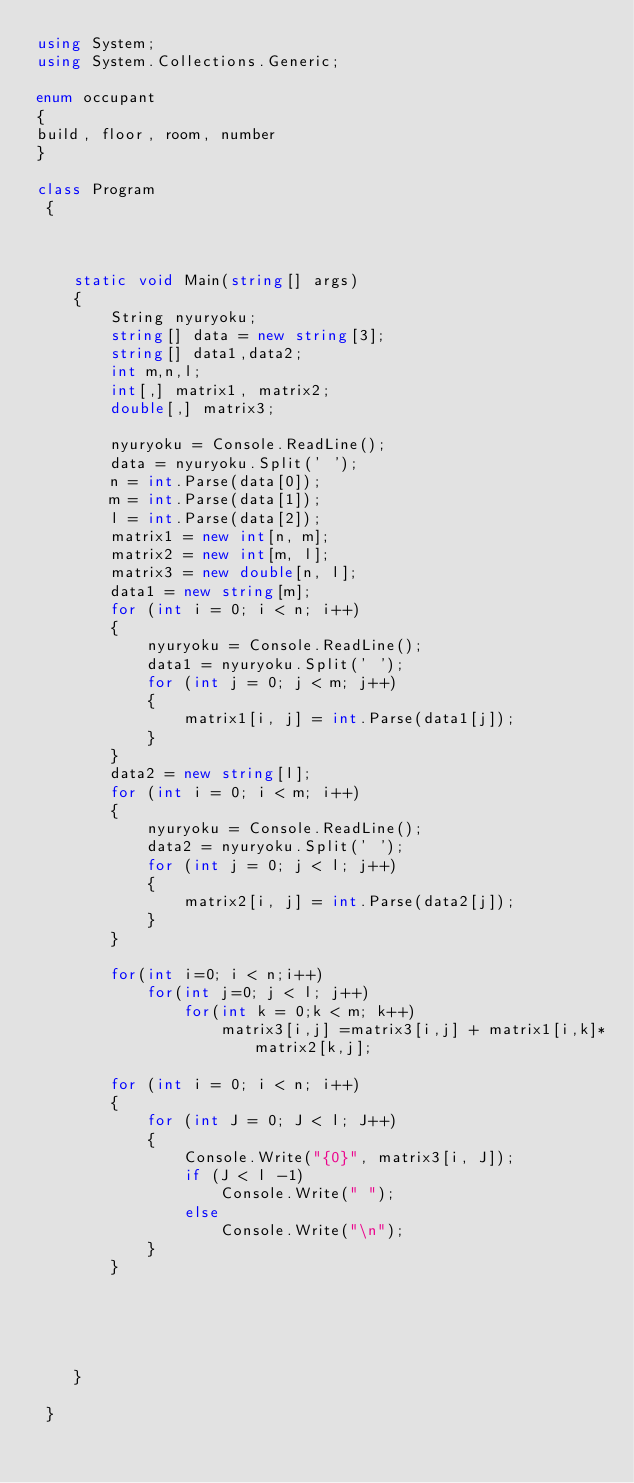<code> <loc_0><loc_0><loc_500><loc_500><_C#_>using System;
using System.Collections.Generic;

enum occupant
{
build, floor, room, number
}

class Program
 {



    static void Main(string[] args)
    {
        String nyuryoku;
        string[] data = new string[3];
        string[] data1,data2;
        int m,n,l;
        int[,] matrix1, matrix2;
        double[,] matrix3;

        nyuryoku = Console.ReadLine();
        data = nyuryoku.Split(' ');
        n = int.Parse(data[0]);
        m = int.Parse(data[1]);
        l = int.Parse(data[2]);
        matrix1 = new int[n, m];
        matrix2 = new int[m, l];
        matrix3 = new double[n, l];
        data1 = new string[m];
        for (int i = 0; i < n; i++)
        {
            nyuryoku = Console.ReadLine();
            data1 = nyuryoku.Split(' ');
            for (int j = 0; j < m; j++)
            {
                matrix1[i, j] = int.Parse(data1[j]);
            }
        }
        data2 = new string[l];
        for (int i = 0; i < m; i++)
        {
            nyuryoku = Console.ReadLine();
            data2 = nyuryoku.Split(' ');
            for (int j = 0; j < l; j++)
            {
                matrix2[i, j] = int.Parse(data2[j]);
            }
        }

        for(int i=0; i < n;i++)
            for(int j=0; j < l; j++)
                for(int k = 0;k < m; k++)
                    matrix3[i,j] =matrix3[i,j] + matrix1[i,k]*matrix2[k,j];

        for (int i = 0; i < n; i++)
        {
            for (int J = 0; J < l; J++)
            {
                Console.Write("{0}", matrix3[i, J]);
                if (J < l -1)
                    Console.Write(" ");
                else
                    Console.Write("\n");
            }
        }





    }

 }

</code> 